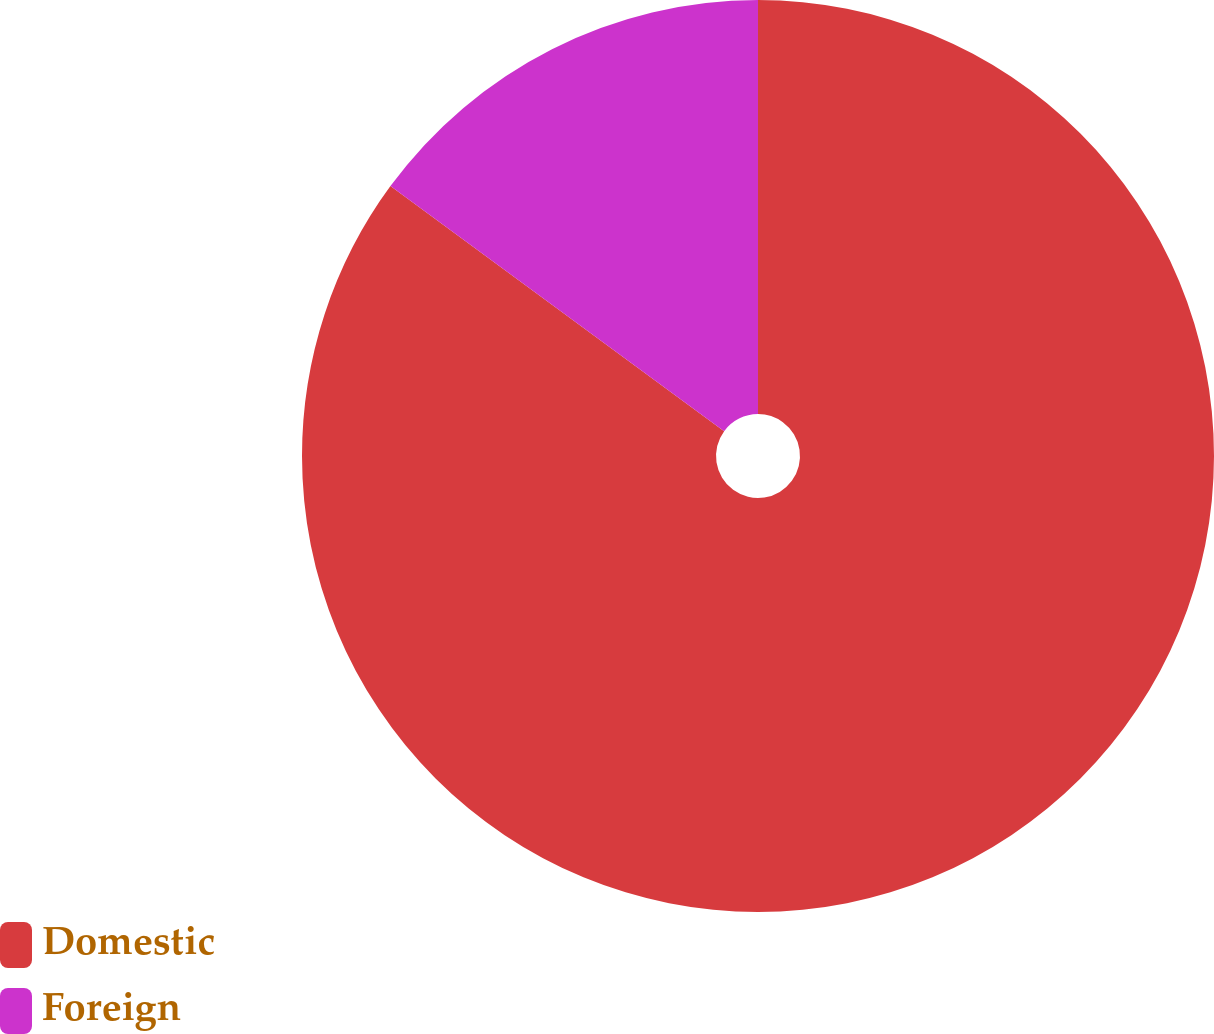Convert chart to OTSL. <chart><loc_0><loc_0><loc_500><loc_500><pie_chart><fcel>Domestic<fcel>Foreign<nl><fcel>85.08%<fcel>14.92%<nl></chart> 